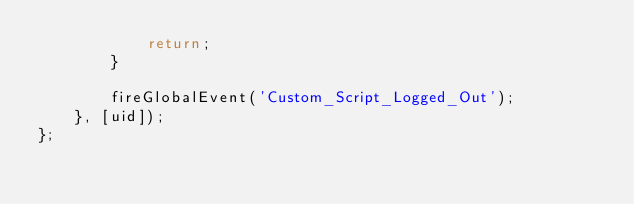Convert code to text. <code><loc_0><loc_0><loc_500><loc_500><_TypeScript_>			return;
		}

		fireGlobalEvent('Custom_Script_Logged_Out');
	}, [uid]);
};
</code> 